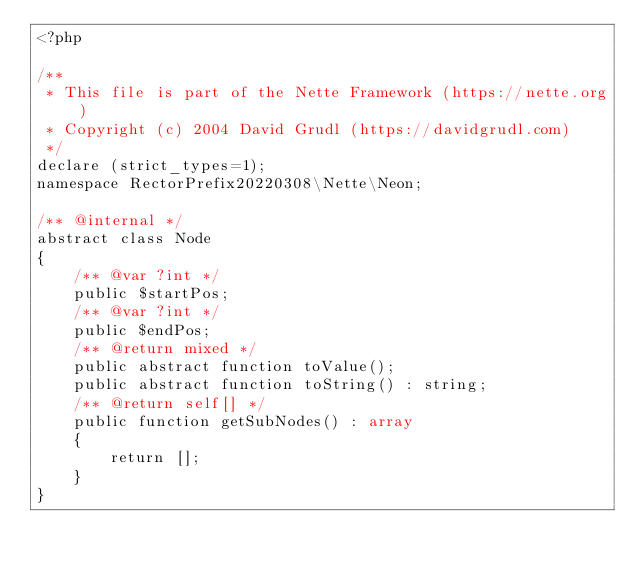<code> <loc_0><loc_0><loc_500><loc_500><_PHP_><?php

/**
 * This file is part of the Nette Framework (https://nette.org)
 * Copyright (c) 2004 David Grudl (https://davidgrudl.com)
 */
declare (strict_types=1);
namespace RectorPrefix20220308\Nette\Neon;

/** @internal */
abstract class Node
{
    /** @var ?int */
    public $startPos;
    /** @var ?int */
    public $endPos;
    /** @return mixed */
    public abstract function toValue();
    public abstract function toString() : string;
    /** @return self[] */
    public function getSubNodes() : array
    {
        return [];
    }
}
</code> 